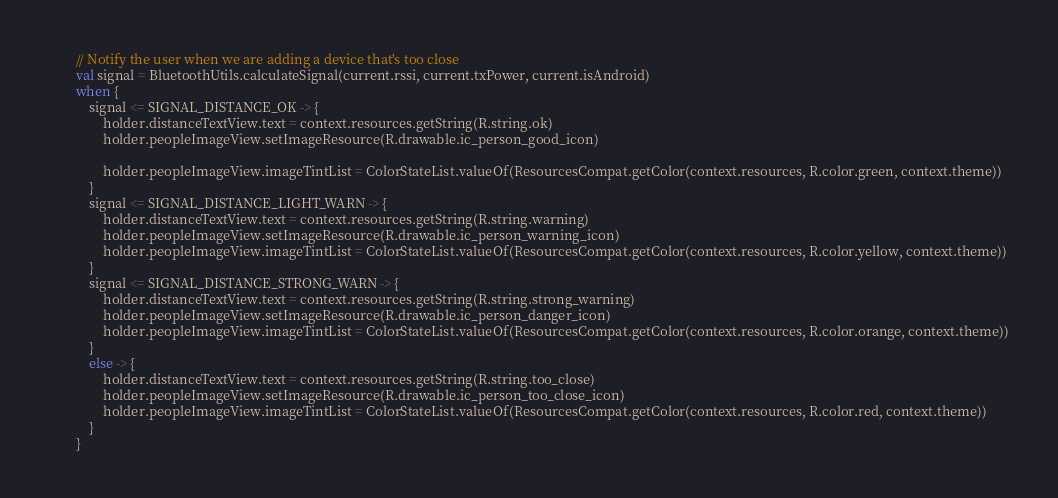Convert code to text. <code><loc_0><loc_0><loc_500><loc_500><_Kotlin_>        // Notify the user when we are adding a device that's too close
        val signal = BluetoothUtils.calculateSignal(current.rssi, current.txPower, current.isAndroid)
        when {
            signal <= SIGNAL_DISTANCE_OK -> {
                holder.distanceTextView.text = context.resources.getString(R.string.ok)
                holder.peopleImageView.setImageResource(R.drawable.ic_person_good_icon)

                holder.peopleImageView.imageTintList = ColorStateList.valueOf(ResourcesCompat.getColor(context.resources, R.color.green, context.theme))
            }
            signal <= SIGNAL_DISTANCE_LIGHT_WARN -> {
                holder.distanceTextView.text = context.resources.getString(R.string.warning)
                holder.peopleImageView.setImageResource(R.drawable.ic_person_warning_icon)
                holder.peopleImageView.imageTintList = ColorStateList.valueOf(ResourcesCompat.getColor(context.resources, R.color.yellow, context.theme))
            }
            signal <= SIGNAL_DISTANCE_STRONG_WARN -> {
                holder.distanceTextView.text = context.resources.getString(R.string.strong_warning)
                holder.peopleImageView.setImageResource(R.drawable.ic_person_danger_icon)
                holder.peopleImageView.imageTintList = ColorStateList.valueOf(ResourcesCompat.getColor(context.resources, R.color.orange, context.theme))
            }
            else -> {
                holder.distanceTextView.text = context.resources.getString(R.string.too_close)
                holder.peopleImageView.setImageResource(R.drawable.ic_person_too_close_icon)
                holder.peopleImageView.imageTintList = ColorStateList.valueOf(ResourcesCompat.getColor(context.resources, R.color.red, context.theme))
            }
        }
</code> 